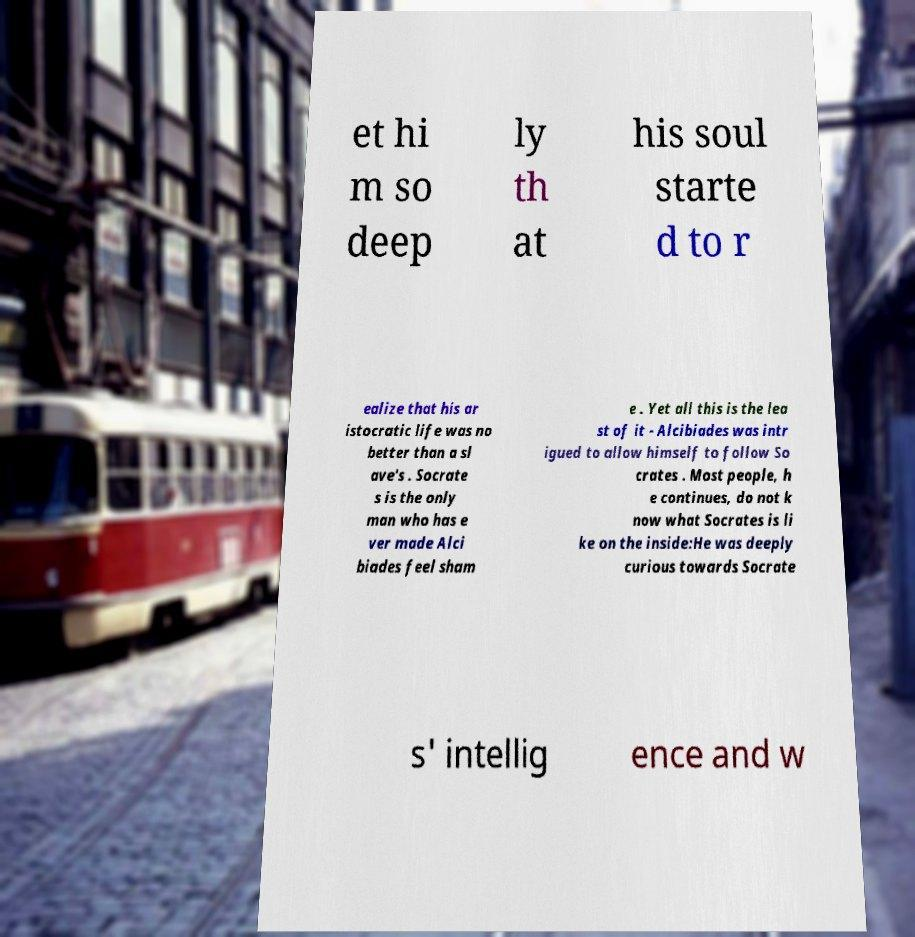Can you accurately transcribe the text from the provided image for me? et hi m so deep ly th at his soul starte d to r ealize that his ar istocratic life was no better than a sl ave's . Socrate s is the only man who has e ver made Alci biades feel sham e . Yet all this is the lea st of it - Alcibiades was intr igued to allow himself to follow So crates . Most people, h e continues, do not k now what Socrates is li ke on the inside:He was deeply curious towards Socrate s' intellig ence and w 